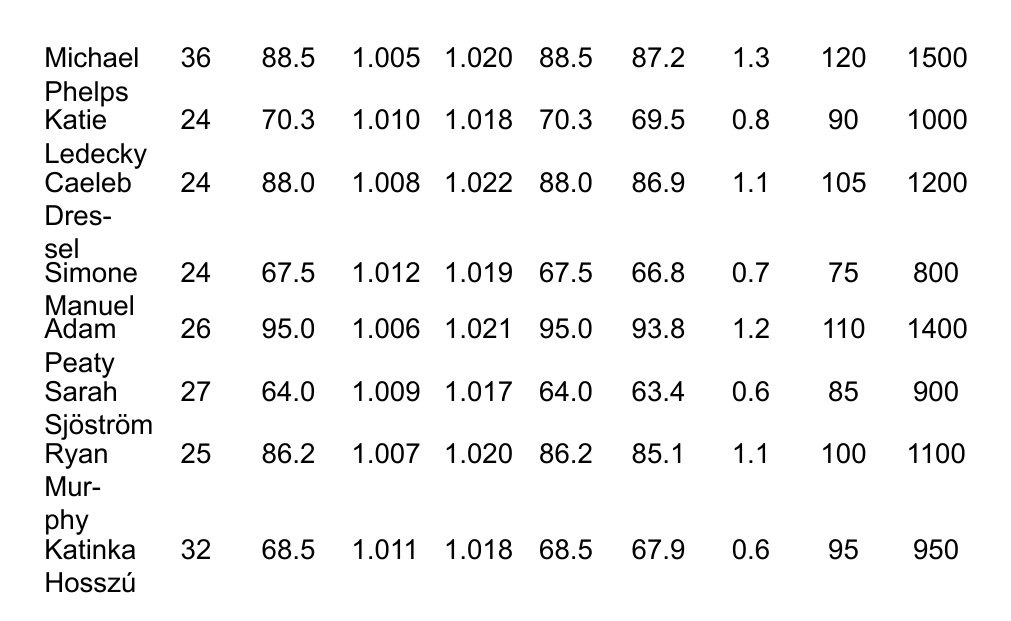What was the sweat rate of Simone Manuel? The sweat rate is listed in the table under the "Sweat Rate (L/hr)" column for Simone Manuel, which shows a value of 0.7 L/hr.
Answer: 0.7 L/hr What is the post-training body mass of Adam Peaty? In the table, the post-training body mass for Adam Peaty is found under the "Post-BM (kg)" column, which shows 93.8 kg.
Answer: 93.8 kg How many minutes did Katie Ledecky train? The training duration for Katie Ledecky is found in the "Duration (min)" column, showing a value of 90 minutes.
Answer: 90 minutes Who had the highest fluid intake during training? To find the highest fluid intake, we compare the "Fluid Intake (mL)" values for each swimmer. Adam Peaty has the highest at 1400 mL.
Answer: Adam Peaty What is the average pre-training urine specific gravity (USG) of the swimmers? The pre-training USG values are 1.005, 1.010, 1.008, 1.012, 1.006, 1.009, 1.007, and 1.011. Adding these gives 8.073, and dividing by 8 gives an average of 1.009125, which rounds to 1.009.
Answer: 1.009 Did any swimmer have a post-training urine specific gravity (USG) lower than 1.015? Looking at each swimmer's post-training USG, Michael Phelps (1.020), Katie Ledecky (1.018), Caeleb Dressel (1.022), Simone Manuel (1.019), Adam Peaty (1.021), Sarah Sjöström (1.017), Ryan Murphy (1.020), and Katinka Hosszú (1.018) all have values above 1.015, indicating none had a post-training USG lower than that threshold.
Answer: No What is the total change in body mass for Ryan Murphy? To find the change in body mass, we take the difference between pre-training (86.2 kg) and post-training (85.1 kg). The difference is 86.2 - 85.1 = 1.1 kg.
Answer: 1.1 kg Which swimmer had the greatest difference in pre-training and post-training body mass? By calculating the differences: Michael Phelps (1.3 kg), Katie Ledecky (0.8 kg), Caeleb Dressel (1.1 kg), Simone Manuel (0.7 kg), Adam Peaty (1.2 kg), Sarah Sjöström (0.6 kg), Ryan Murphy (1.1 kg), and Katinka Hosszú (0.6 kg), Michael Phelps shows the greatest difference of 1.3 kg.
Answer: Michael Phelps What is the average weight of the swimmers listed in the table? The weights are 88.5, 70.3, 88.0, 67.5, 95.0, 64.0, 86.2, and 68.5 kg. The sum is 70.3 + 64.0 + 67.5 + 68.5 + 86.2 + 88.0 + 95.0 + 88.5 = 564.0 kg, and dividing by 8 gives an average of 70.5 kg.
Answer: 70.5 kg Was there a swimmer who had a pre-training urine specific gravity (USG) of exactly 1.010? Reviewing the "Pre-USG" column, Katie Ledecky has a pre-training USG of 1.010, confirming there was a swimmer with this exact value.
Answer: Yes 